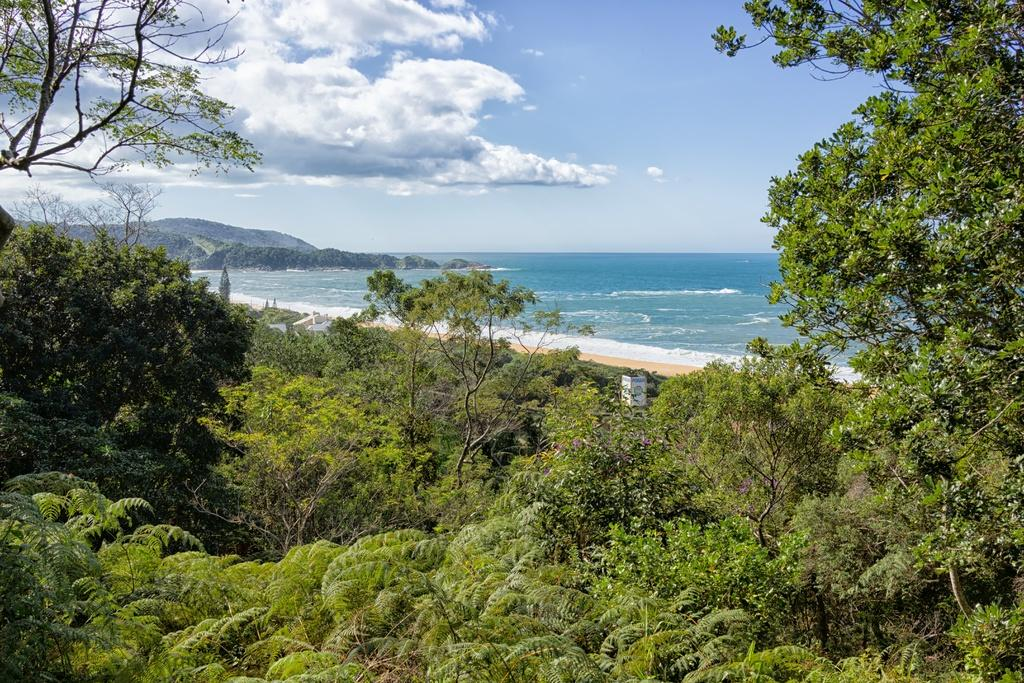What type of vegetation is in the foreground of the image? There are trees in the foreground of the image. What type of landscape feature can be seen in the background of the image? There are hills in the background of the image. What is the condition of the sky in the image? The sky is cloudy in the image. Can you see a crib in the image? There is no crib present in the image. Is there a boat visible in the image? There is no boat present in the image. 